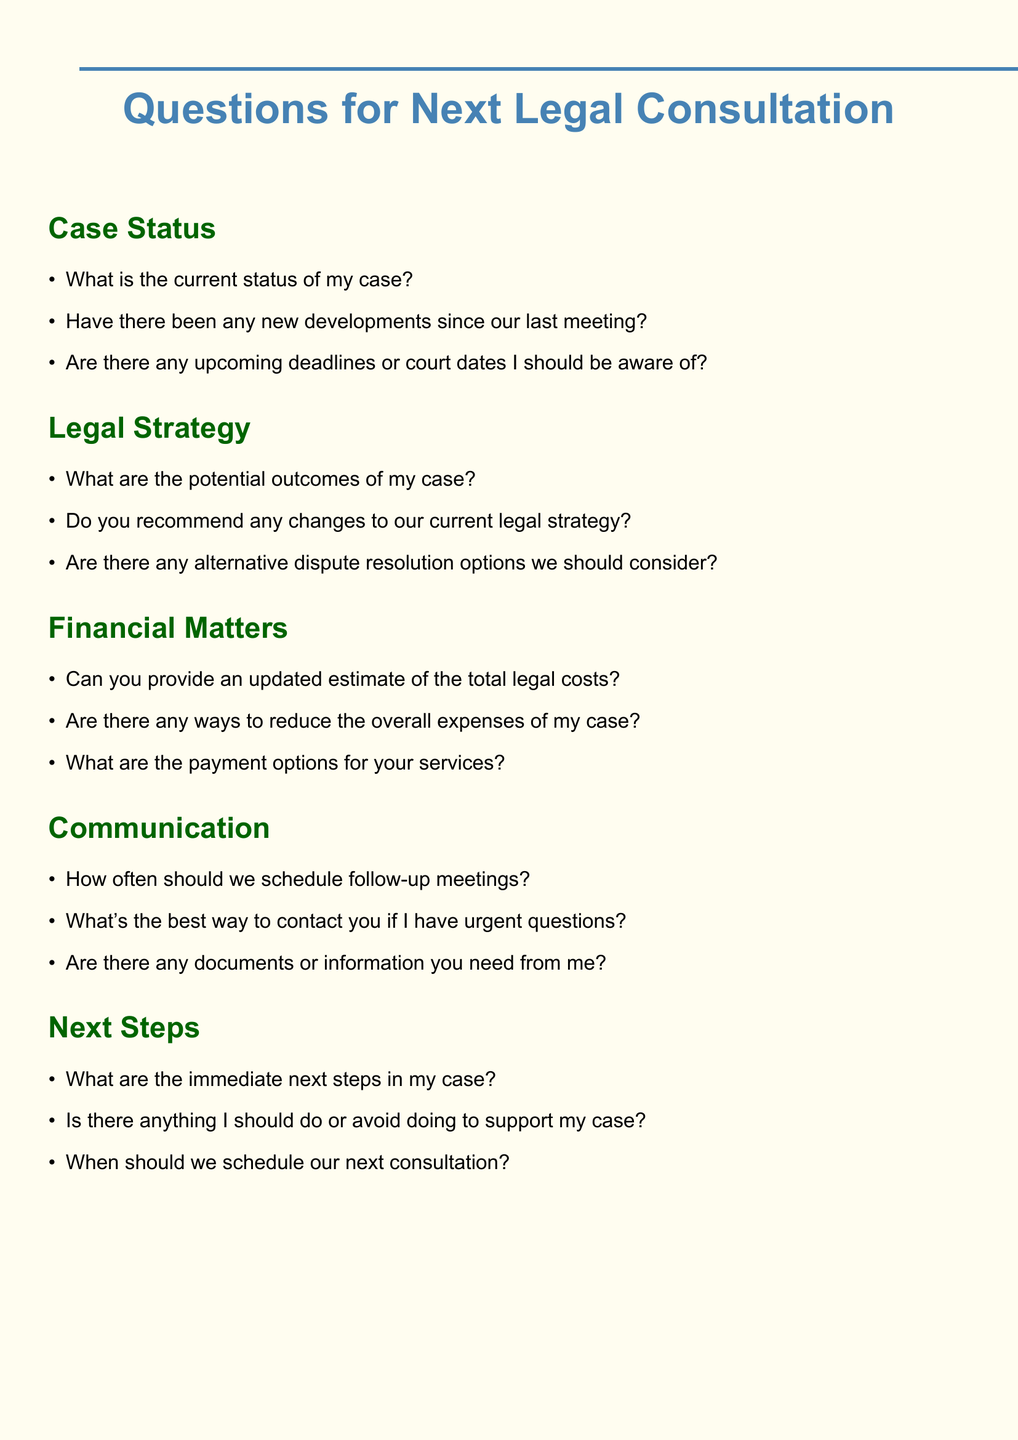What is the title of the document? The title is explicitly stated at the beginning of the document.
Answer: Questions for Next Legal Consultation How many sections are in the document? Each section is highlighted in the format of headings throughout the document.
Answer: Five What is one example of a question under 'Case Status'? "Case Status" has several questions listed underneath it.
Answer: What is the current status of my case? What are the potential outcomes of my case? This question is found under the 'Legal Strategy' section, indicating its importance.
Answer: What are the potential outcomes of my case? What is the recommended payment option type mentioned? The answer is found in the 'Financial Matters' section, which discusses payment options.
Answer: What are the payment options for your services? 